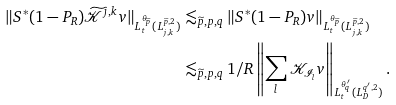<formula> <loc_0><loc_0><loc_500><loc_500>\| S ^ { * } ( 1 - P _ { R } ) \widetilde { \mathcal { K } } ^ { j , k } v \| _ { L _ { t } ^ { \theta _ { \widetilde { p } } } ( L ^ { \widetilde { p } , 2 } _ { j , k } ) } & \lesssim _ { \widetilde { p } , p , q } \| S ^ { * } ( 1 - P _ { R } ) v \| _ { L _ { t } ^ { \theta _ { \widetilde { p } } } ( L ^ { \widetilde { p } , 2 } _ { j , k } ) } \\ & \lesssim _ { \widetilde { p } , p , q } 1 / R \left \| \sum _ { l } \mathcal { K } _ { \mathcal { I } _ { l } } v \right \| _ { L _ { t } ^ { \theta _ { q } ^ { \prime } } ( L ^ { q ^ { \prime } , 2 } _ { D } ) } .</formula> 